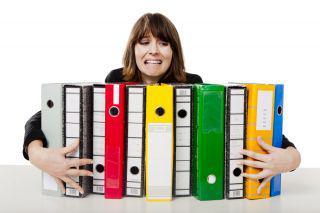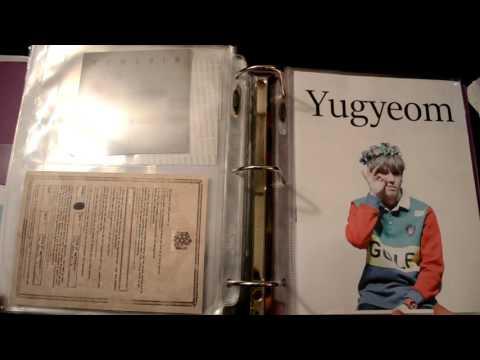The first image is the image on the left, the second image is the image on the right. Evaluate the accuracy of this statement regarding the images: "There is one open binder in the right image.". Is it true? Answer yes or no. Yes. 